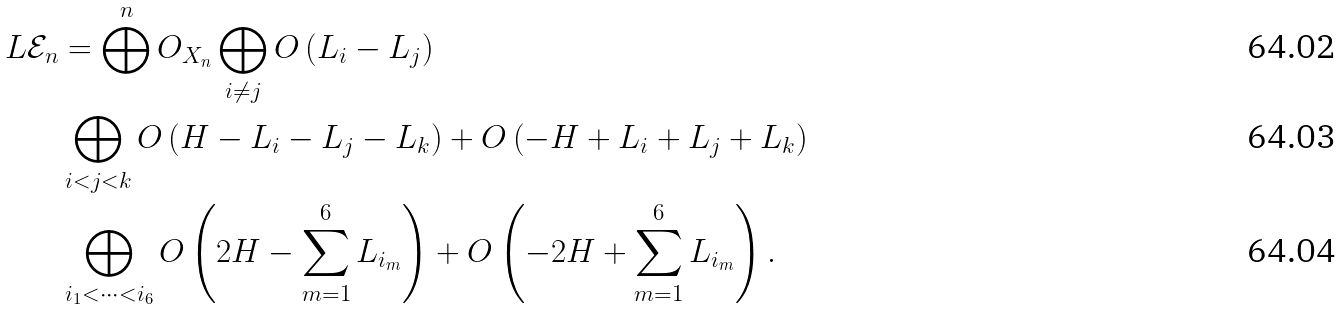Convert formula to latex. <formula><loc_0><loc_0><loc_500><loc_500>L \mathcal { E } _ { n } & = \bigoplus ^ { n } O _ { X _ { n } } \bigoplus _ { i \neq j } O \left ( L _ { i } - L _ { j } \right ) \\ & \bigoplus _ { i < j < k } O \left ( H - L _ { i } - L _ { j } - L _ { k } \right ) + O \left ( - H + L _ { i } + L _ { j } + L _ { k } \right ) \\ & \bigoplus _ { i _ { 1 } < \dots < i _ { 6 } } O \left ( 2 H - \sum _ { m = 1 } ^ { 6 } L _ { i _ { m } } \right ) + O \left ( - 2 H + \sum _ { m = 1 } ^ { 6 } L _ { i _ { m } } \right ) .</formula> 